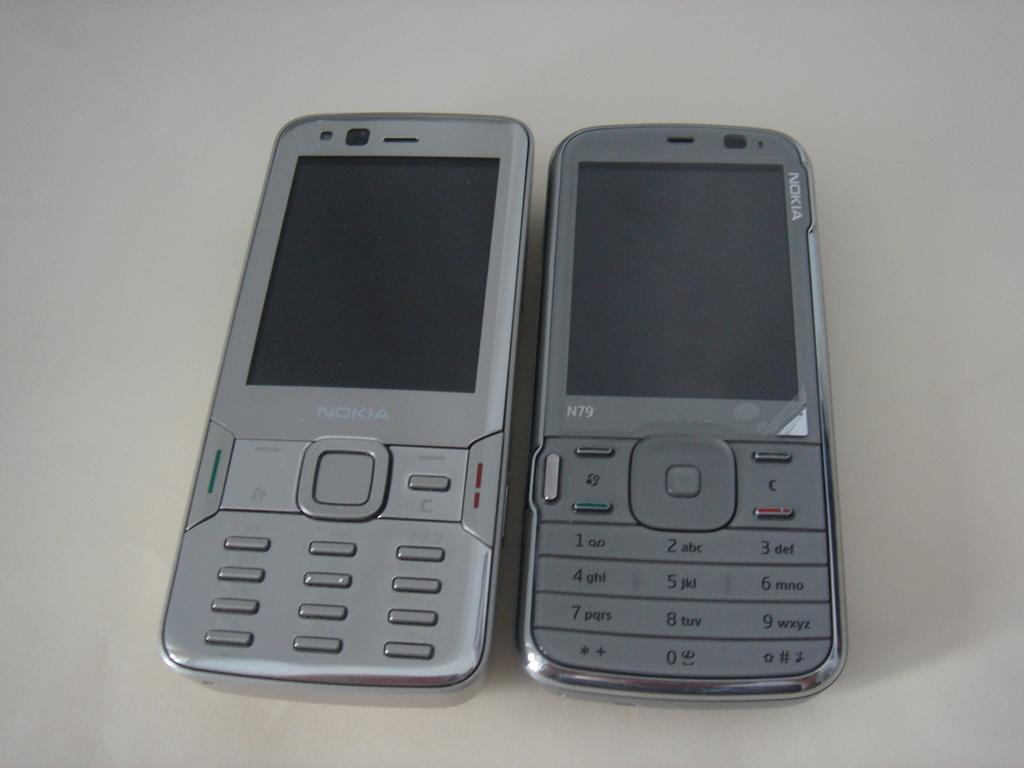<image>
Render a clear and concise summary of the photo. Two nokia brand phone are lying on a table. 